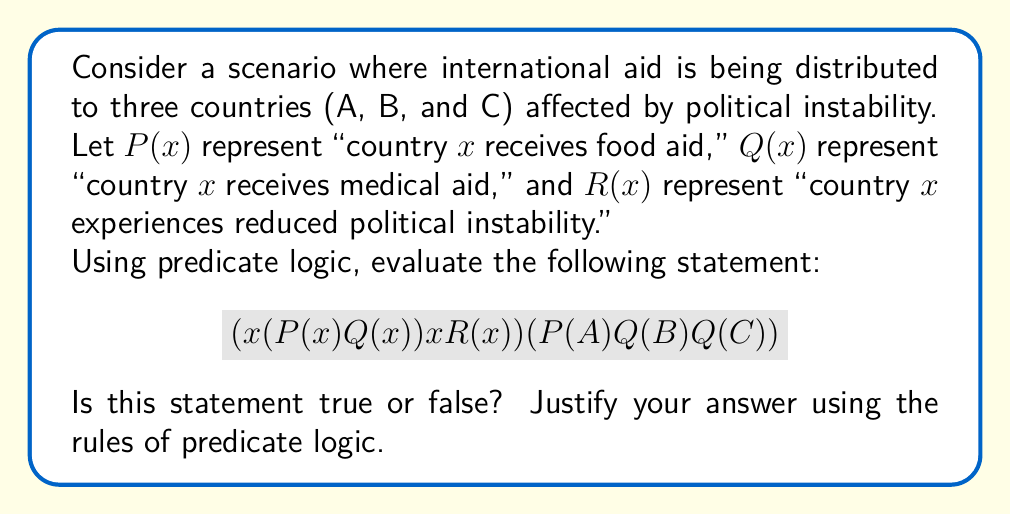What is the answer to this math problem? Let's break down this problem step-by-step:

1) First, let's understand the given statement:
   $$(∀x(P(x) ∧ Q(x)) → ∃xR(x)) ∧ (P(A) ∧ Q(B) ∧ ¬Q(C))$$

   This statement is a conjunction of two parts:
   Part 1: $∀x(P(x) ∧ Q(x)) → ∃xR(x)$
   Part 2: $P(A) ∧ Q(B) ∧ ¬Q(C)$

2) Let's evaluate Part 2 first:
   $P(A)$: Country A receives food aid
   $Q(B)$: Country B receives medical aid
   $¬Q(C)$: Country C does not receive medical aid

3) Now, let's look at Part 1: $∀x(P(x) ∧ Q(x)) → ∃xR(x)$
   This states that if all countries receive both food and medical aid, then at least one country experiences reduced political instability.

4) However, from Part 2, we know that not all countries receive both types of aid:
   - Country A receives food aid, but we don't know about medical aid
   - Country B receives medical aid, but we don't know about food aid
   - Country C does not receive medical aid

5) Therefore, the antecedent of the implication in Part 1 ($∀x(P(x) ∧ Q(x))$) is false.

6) In predicate logic, when the antecedent of an implication is false, the entire implication is true, regardless of the consequent.

7) Thus, Part 1 is true.

8) Since both Part 1 and Part 2 are true, their conjunction is also true.

Therefore, the entire statement is true.
Answer: True 